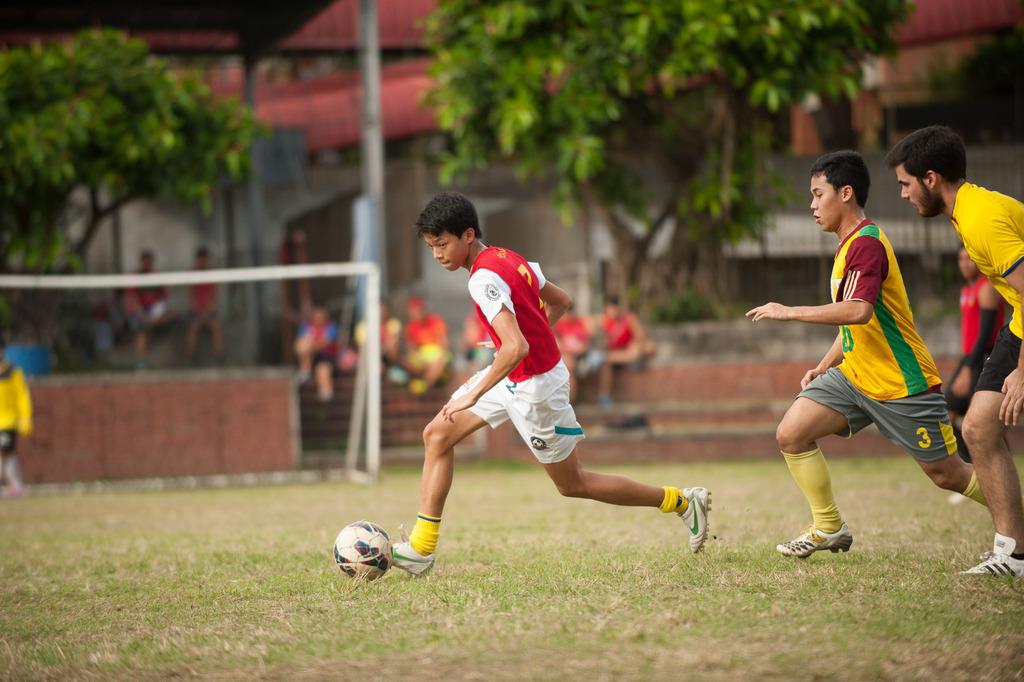What is the boy in yellows jersey number?
Your answer should be compact. 3. 